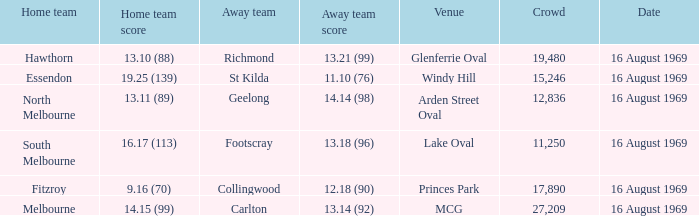What was the away team's score at Princes Park? 12.18 (90). 